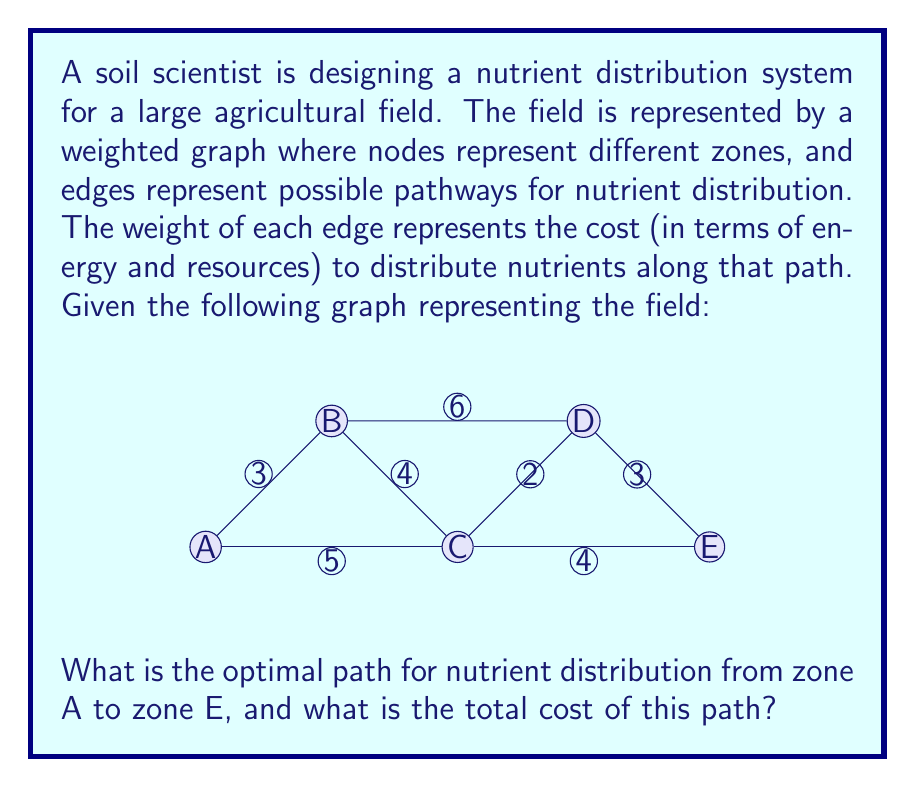Can you answer this question? To solve this problem, we can use Dijkstra's algorithm, which is an efficient method for finding the shortest path in a weighted graph.

Step 1: Initialize distances
Set the distance to A as 0 and all other nodes as infinity.
$$d(A) = 0, d(B) = d(C) = d(D) = d(E) = \infty$$

Step 2: Visit node A
Update distances to neighbors:
$$d(B) = \min(\infty, 0 + 3) = 3$$
$$d(C) = \min(\infty, 0 + 5) = 5$$

Step 3: Visit node B (closest unvisited node)
Update distances:
$$d(C) = \min(5, 3 + 4) = 5$$
$$d(D) = \min(\infty, 3 + 6) = 9$$

Step 4: Visit node C
Update distances:
$$d(D) = \min(9, 5 + 2) = 7$$
$$d(E) = \min(\infty, 5 + 4) = 9$$

Step 5: Visit node D
Update distance:
$$d(E) = \min(9, 7 + 3) = 9$$

Step 6: Visit node E
All nodes visited, algorithm terminates.

The shortest path from A to E is A → C → E with a total cost of 9.
Answer: Path: A → C → E, Cost: 9 